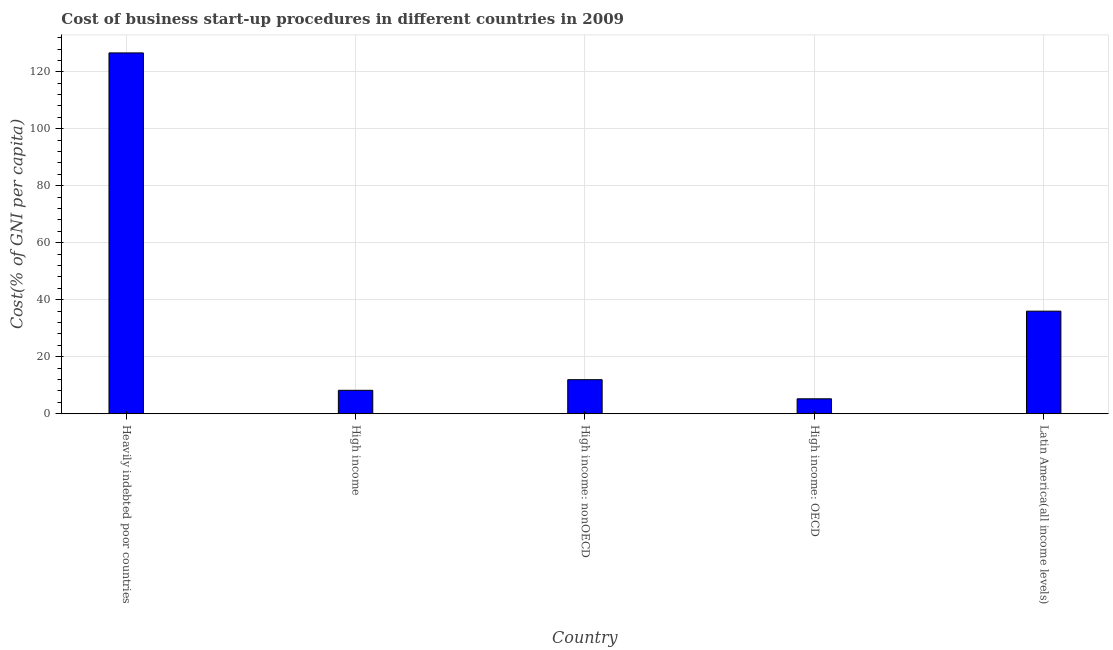Does the graph contain any zero values?
Ensure brevity in your answer.  No. What is the title of the graph?
Offer a very short reply. Cost of business start-up procedures in different countries in 2009. What is the label or title of the Y-axis?
Make the answer very short. Cost(% of GNI per capita). What is the cost of business startup procedures in High income?
Keep it short and to the point. 8.23. Across all countries, what is the maximum cost of business startup procedures?
Keep it short and to the point. 126.63. Across all countries, what is the minimum cost of business startup procedures?
Give a very brief answer. 5.24. In which country was the cost of business startup procedures maximum?
Keep it short and to the point. Heavily indebted poor countries. In which country was the cost of business startup procedures minimum?
Give a very brief answer. High income: OECD. What is the sum of the cost of business startup procedures?
Your answer should be compact. 188.05. What is the difference between the cost of business startup procedures in High income and Latin America(all income levels)?
Give a very brief answer. -27.77. What is the average cost of business startup procedures per country?
Offer a terse response. 37.61. What is the median cost of business startup procedures?
Your response must be concise. 11.95. What is the ratio of the cost of business startup procedures in Heavily indebted poor countries to that in High income: nonOECD?
Your answer should be very brief. 10.59. Is the cost of business startup procedures in High income less than that in High income: nonOECD?
Offer a terse response. Yes. What is the difference between the highest and the second highest cost of business startup procedures?
Keep it short and to the point. 90.63. Is the sum of the cost of business startup procedures in High income: OECD and Latin America(all income levels) greater than the maximum cost of business startup procedures across all countries?
Give a very brief answer. No. What is the difference between the highest and the lowest cost of business startup procedures?
Your answer should be very brief. 121.39. In how many countries, is the cost of business startup procedures greater than the average cost of business startup procedures taken over all countries?
Your answer should be compact. 1. How many countries are there in the graph?
Offer a very short reply. 5. What is the difference between two consecutive major ticks on the Y-axis?
Offer a very short reply. 20. Are the values on the major ticks of Y-axis written in scientific E-notation?
Provide a short and direct response. No. What is the Cost(% of GNI per capita) of Heavily indebted poor countries?
Offer a very short reply. 126.63. What is the Cost(% of GNI per capita) of High income?
Keep it short and to the point. 8.23. What is the Cost(% of GNI per capita) of High income: nonOECD?
Keep it short and to the point. 11.95. What is the Cost(% of GNI per capita) of High income: OECD?
Keep it short and to the point. 5.24. What is the Cost(% of GNI per capita) of Latin America(all income levels)?
Offer a terse response. 36. What is the difference between the Cost(% of GNI per capita) in Heavily indebted poor countries and High income?
Your answer should be very brief. 118.4. What is the difference between the Cost(% of GNI per capita) in Heavily indebted poor countries and High income: nonOECD?
Give a very brief answer. 114.67. What is the difference between the Cost(% of GNI per capita) in Heavily indebted poor countries and High income: OECD?
Your response must be concise. 121.39. What is the difference between the Cost(% of GNI per capita) in Heavily indebted poor countries and Latin America(all income levels)?
Make the answer very short. 90.63. What is the difference between the Cost(% of GNI per capita) in High income and High income: nonOECD?
Offer a very short reply. -3.73. What is the difference between the Cost(% of GNI per capita) in High income and High income: OECD?
Your response must be concise. 2.98. What is the difference between the Cost(% of GNI per capita) in High income and Latin America(all income levels)?
Give a very brief answer. -27.77. What is the difference between the Cost(% of GNI per capita) in High income: nonOECD and High income: OECD?
Offer a terse response. 6.71. What is the difference between the Cost(% of GNI per capita) in High income: nonOECD and Latin America(all income levels)?
Ensure brevity in your answer.  -24.04. What is the difference between the Cost(% of GNI per capita) in High income: OECD and Latin America(all income levels)?
Offer a very short reply. -30.75. What is the ratio of the Cost(% of GNI per capita) in Heavily indebted poor countries to that in High income?
Provide a succinct answer. 15.39. What is the ratio of the Cost(% of GNI per capita) in Heavily indebted poor countries to that in High income: nonOECD?
Provide a succinct answer. 10.59. What is the ratio of the Cost(% of GNI per capita) in Heavily indebted poor countries to that in High income: OECD?
Your answer should be compact. 24.15. What is the ratio of the Cost(% of GNI per capita) in Heavily indebted poor countries to that in Latin America(all income levels)?
Provide a succinct answer. 3.52. What is the ratio of the Cost(% of GNI per capita) in High income to that in High income: nonOECD?
Offer a terse response. 0.69. What is the ratio of the Cost(% of GNI per capita) in High income to that in High income: OECD?
Your answer should be compact. 1.57. What is the ratio of the Cost(% of GNI per capita) in High income to that in Latin America(all income levels)?
Ensure brevity in your answer.  0.23. What is the ratio of the Cost(% of GNI per capita) in High income: nonOECD to that in High income: OECD?
Offer a terse response. 2.28. What is the ratio of the Cost(% of GNI per capita) in High income: nonOECD to that in Latin America(all income levels)?
Give a very brief answer. 0.33. What is the ratio of the Cost(% of GNI per capita) in High income: OECD to that in Latin America(all income levels)?
Provide a short and direct response. 0.15. 